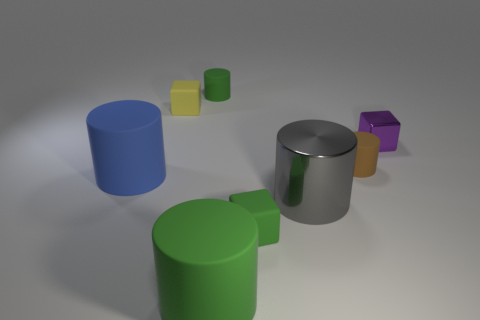How many other objects have the same material as the tiny purple object?
Provide a short and direct response. 1. How many things are either large objects in front of the blue rubber cylinder or rubber things?
Give a very brief answer. 7. The brown object is what size?
Provide a succinct answer. Small. There is a tiny cube to the right of the metallic thing that is in front of the brown rubber cylinder; what is it made of?
Make the answer very short. Metal. There is a matte block that is in front of the blue thing; is it the same size as the blue cylinder?
Your answer should be very brief. No. What number of things are matte cylinders behind the large metal cylinder or small matte objects that are to the left of the small brown cylinder?
Provide a succinct answer. 5. Do the metal cylinder and the metallic block have the same color?
Provide a short and direct response. No. Is the number of cubes that are in front of the large metallic object less than the number of small yellow things to the right of the tiny purple shiny cube?
Give a very brief answer. No. Are the purple object and the big gray object made of the same material?
Your answer should be compact. Yes. There is a block that is both left of the big shiny thing and behind the large gray object; what size is it?
Give a very brief answer. Small. 